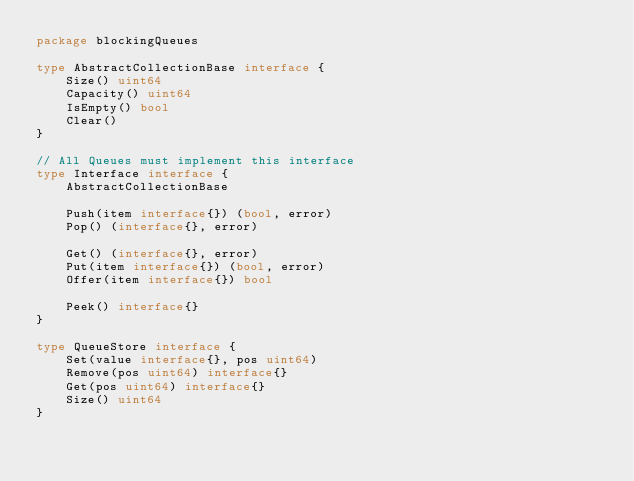<code> <loc_0><loc_0><loc_500><loc_500><_Go_>package blockingQueues

type AbstractCollectionBase interface {
	Size() uint64
	Capacity() uint64
	IsEmpty() bool
	Clear()
}

// All Queues must implement this interface
type Interface interface {
	AbstractCollectionBase

	Push(item interface{}) (bool, error)
	Pop() (interface{}, error)

	Get() (interface{}, error)
	Put(item interface{}) (bool, error)
	Offer(item interface{}) bool

	Peek() interface{}
}

type QueueStore interface {
	Set(value interface{}, pos uint64)
	Remove(pos uint64) interface{}
	Get(pos uint64) interface{}
	Size() uint64
}
</code> 